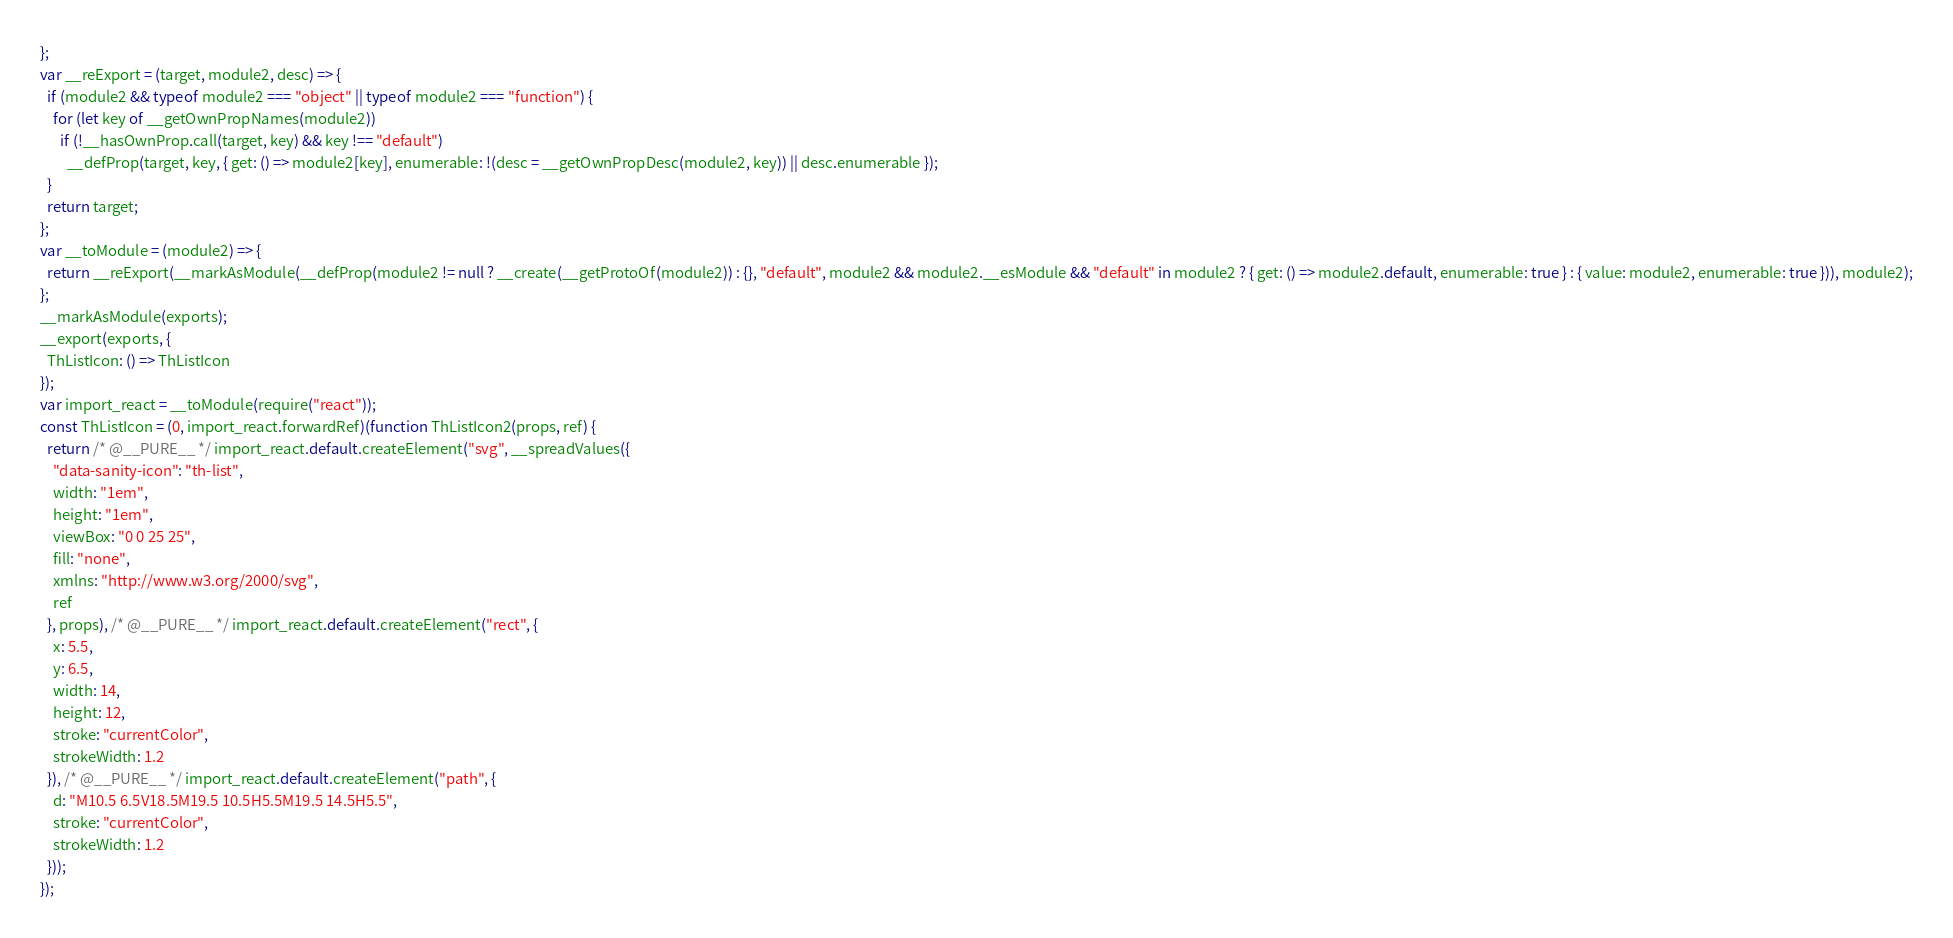Convert code to text. <code><loc_0><loc_0><loc_500><loc_500><_JavaScript_>};
var __reExport = (target, module2, desc) => {
  if (module2 && typeof module2 === "object" || typeof module2 === "function") {
    for (let key of __getOwnPropNames(module2))
      if (!__hasOwnProp.call(target, key) && key !== "default")
        __defProp(target, key, { get: () => module2[key], enumerable: !(desc = __getOwnPropDesc(module2, key)) || desc.enumerable });
  }
  return target;
};
var __toModule = (module2) => {
  return __reExport(__markAsModule(__defProp(module2 != null ? __create(__getProtoOf(module2)) : {}, "default", module2 && module2.__esModule && "default" in module2 ? { get: () => module2.default, enumerable: true } : { value: module2, enumerable: true })), module2);
};
__markAsModule(exports);
__export(exports, {
  ThListIcon: () => ThListIcon
});
var import_react = __toModule(require("react"));
const ThListIcon = (0, import_react.forwardRef)(function ThListIcon2(props, ref) {
  return /* @__PURE__ */ import_react.default.createElement("svg", __spreadValues({
    "data-sanity-icon": "th-list",
    width: "1em",
    height: "1em",
    viewBox: "0 0 25 25",
    fill: "none",
    xmlns: "http://www.w3.org/2000/svg",
    ref
  }, props), /* @__PURE__ */ import_react.default.createElement("rect", {
    x: 5.5,
    y: 6.5,
    width: 14,
    height: 12,
    stroke: "currentColor",
    strokeWidth: 1.2
  }), /* @__PURE__ */ import_react.default.createElement("path", {
    d: "M10.5 6.5V18.5M19.5 10.5H5.5M19.5 14.5H5.5",
    stroke: "currentColor",
    strokeWidth: 1.2
  }));
});
</code> 